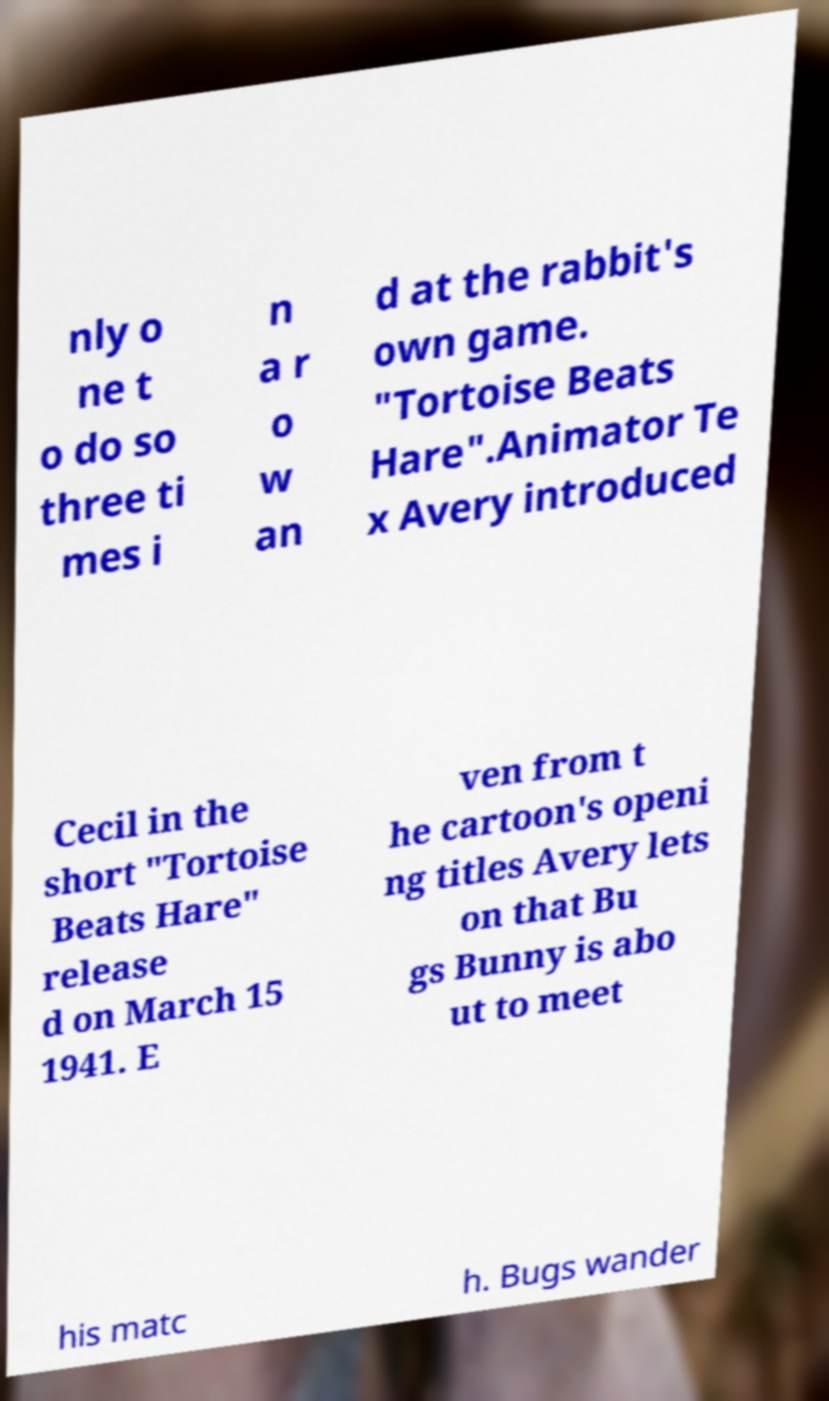Could you assist in decoding the text presented in this image and type it out clearly? nly o ne t o do so three ti mes i n a r o w an d at the rabbit's own game. "Tortoise Beats Hare".Animator Te x Avery introduced Cecil in the short "Tortoise Beats Hare" release d on March 15 1941. E ven from t he cartoon's openi ng titles Avery lets on that Bu gs Bunny is abo ut to meet his matc h. Bugs wander 